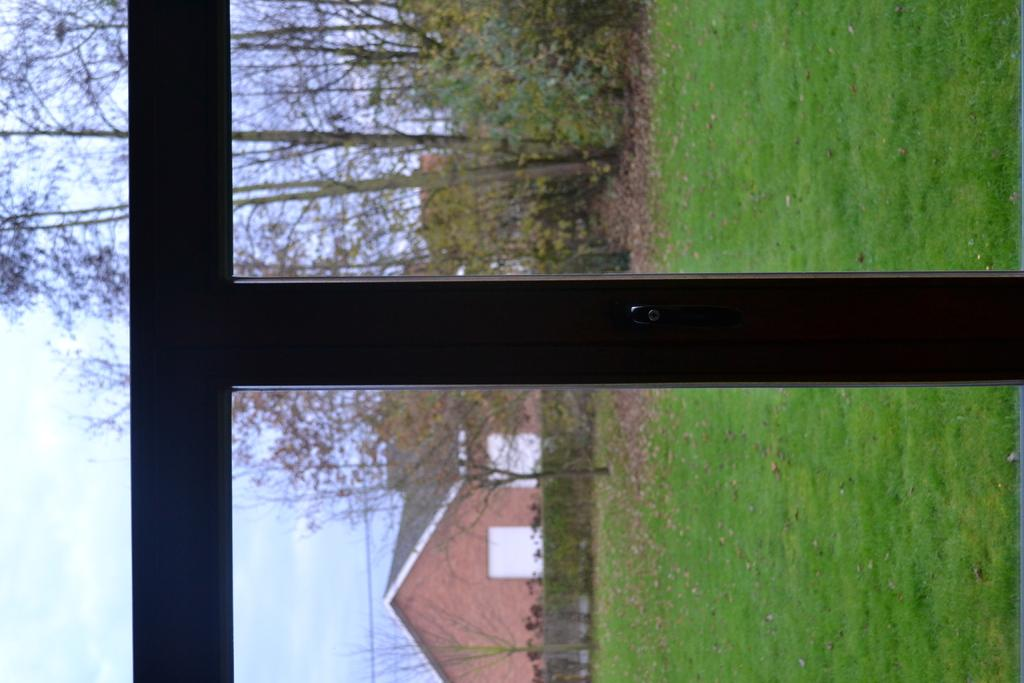What type of window is shown in the image? There is a window made of glass and wood in the image. What can be seen through the window? A building, a group of trees, and a fence are visible from the window. What is visible in the background of the image? The sky is visible in the background of the image. What type of crime is being committed in the image? There is no indication of any crime being committed in the image. How many attempts were made to break into the house in the image? There is no house or any indication of an attempted break-in in the image. 